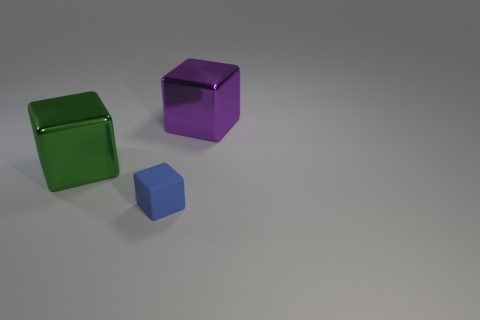There is a metallic object that is to the left of the thing in front of the big green block; what is its size?
Provide a short and direct response. Large. Are there the same number of big green things that are in front of the large purple thing and purple metallic objects?
Your answer should be very brief. Yes. The matte object that is the same shape as the large purple metallic object is what color?
Ensure brevity in your answer.  Blue. Is the big purple cube that is on the right side of the small rubber object made of the same material as the blue thing?
Provide a succinct answer. No. What number of big things are blue objects or red metallic blocks?
Make the answer very short. 0. The green block is what size?
Offer a very short reply. Large. There is a purple metal cube; does it have the same size as the object that is in front of the green cube?
Ensure brevity in your answer.  No. What number of gray objects are either matte blocks or metal cubes?
Make the answer very short. 0. What number of tiny matte objects are there?
Your answer should be compact. 1. There is a object to the right of the blue cube; how big is it?
Provide a short and direct response. Large. 